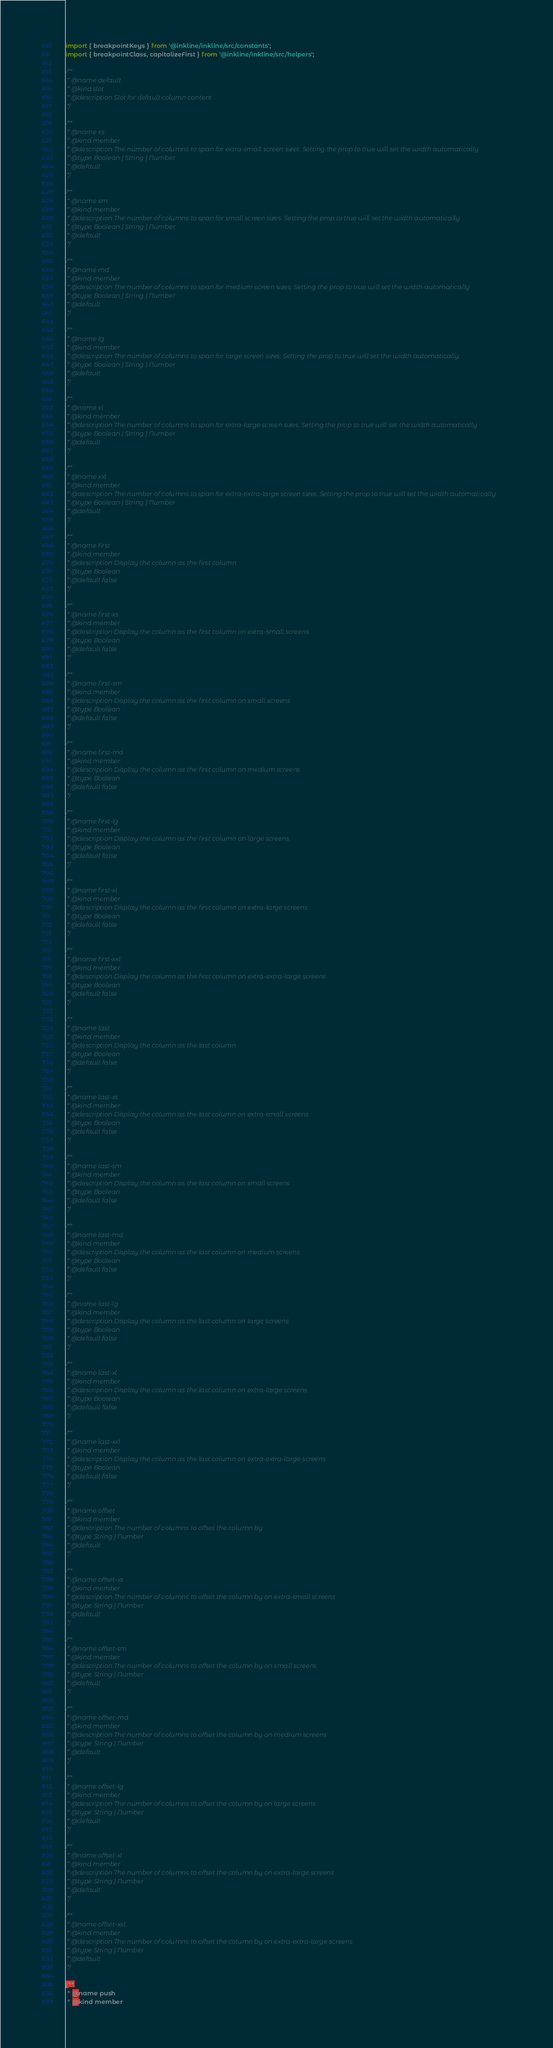Convert code to text. <code><loc_0><loc_0><loc_500><loc_500><_JavaScript_>import { breakpointKeys } from '@inkline/inkline/src/constants';
import { breakpointClass, capitalizeFirst } from '@inkline/inkline/src/helpers';

/**
 * @name default
 * @kind slot
 * @description Slot for default column content
 */

/**
 * @name xs
 * @kind member
 * @description The number of columns to span for extra-small screen sizes. Setting the prop to true will set the width automatically
 * @type Boolean | String | Number
 * @default
 */

/**
 * @name sm
 * @kind member
 * @description The number of columns to span for small screen sizes. Setting the prop to true will set the width automatically
 * @type Boolean | String | Number
 * @default
 */

/**
 * @name md
 * @kind member
 * @description The number of columns to span for medium screen sizes. Setting the prop to true will set the width automatically
 * @type Boolean | String | Number
 * @default
 */

/**
 * @name lg
 * @kind member
 * @description The number of columns to span for large screen sizes. Setting the prop to true will set the width automatically
 * @type Boolean | String | Number
 * @default
 */

/**
 * @name xl
 * @kind member
 * @description The number of columns to span for extra-large screen sizes. Setting the prop to true will set the width automatically
 * @type Boolean | String | Number
 * @default
 */

/**
 * @name xxl
 * @kind member
 * @description The number of columns to span for extra-extra-large screen sizes. Setting the prop to true will set the width automatically
 * @type Boolean | String | Number
 * @default
 */

/**
 * @name first
 * @kind member
 * @description Display the column as the first column
 * @type Boolean
 * @default false
 */

/**
 * @name first-xs
 * @kind member
 * @description Display the column as the first column on extra-small screens
 * @type Boolean
 * @default false
 */

/**
 * @name first-sm
 * @kind member
 * @description Display the column as the first column on small screens
 * @type Boolean
 * @default false
 */

/**
 * @name first-md
 * @kind member
 * @description Display the column as the first column on medium screens
 * @type Boolean
 * @default false
 */

/**
 * @name first-lg
 * @kind member
 * @description Display the column as the first column on large screens
 * @type Boolean
 * @default false
 */

/**
 * @name first-xl
 * @kind member
 * @description Display the column as the first column on extra-large screens
 * @type Boolean
 * @default false
 */

/**
 * @name first-xxl
 * @kind member
 * @description Display the column as the first column on extra-extra-large screens
 * @type Boolean
 * @default false
 */

/**
 * @name last
 * @kind member
 * @description Display the column as the last column
 * @type Boolean
 * @default false
 */

/**
 * @name last-xs
 * @kind member
 * @description Display the column as the last column on extra-small screens
 * @type Boolean
 * @default false
 */

/**
 * @name last-sm
 * @kind member
 * @description Display the column as the last column on small screens
 * @type Boolean
 * @default false
 */

/**
 * @name last-md
 * @kind member
 * @description Display the column as the last column on medium screens
 * @type Boolean
 * @default false
 */

/**
 * @name last-lg
 * @kind member
 * @description Display the column as the last column on large screens
 * @type Boolean
 * @default false
 */

/**
 * @name last-xl
 * @kind member
 * @description Display the column as the last column on extra-large screens
 * @type Boolean
 * @default false
 */

/**
 * @name last-xxl
 * @kind member
 * @description Display the column as the last column on extra-extra-large screens
 * @type Boolean
 * @default false
 */

/**
 * @name offset
 * @kind member
 * @description The number of columns to offset the column by
 * @type String | Number
 * @default
 */

/**
 * @name offset-xs
 * @kind member
 * @description The number of columns to offset the column by on extra-small screens
 * @type String | Number
 * @default
 */

/**
 * @name offset-sm
 * @kind member
 * @description The number of columns to offset the column by on small screens
 * @type String | Number
 * @default
 */

/**
 * @name offset-md
 * @kind member
 * @description The number of columns to offset the column by on medium screens
 * @type String | Number
 * @default
 */

/**
 * @name offset-lg
 * @kind member
 * @description The number of columns to offset the column by on large screens
 * @type String | Number
 * @default
 */

/**
 * @name offset-xl
 * @kind member
 * @description The number of columns to offset the column by on extra-large screens
 * @type String | Number
 * @default
 */

/**
 * @name offset-xxl
 * @kind member
 * @description The number of columns to offset the column by on extra-extra-large screens
 * @type String | Number
 * @default
 */

/**
 * @name push
 * @kind member</code> 